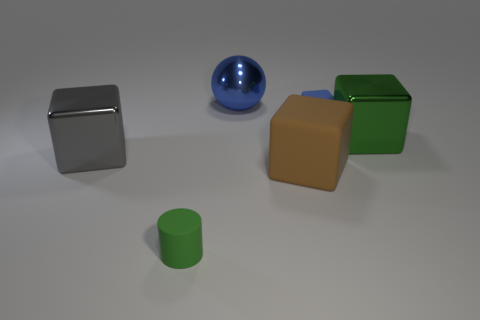What number of other things are there of the same size as the green shiny thing?
Give a very brief answer. 3. There is a brown object that is the same shape as the gray object; what is it made of?
Your answer should be very brief. Rubber. What is the material of the green thing behind the tiny thing in front of the green object that is behind the big rubber thing?
Your response must be concise. Metal. The other cube that is made of the same material as the big gray cube is what size?
Offer a terse response. Large. Is there any other thing of the same color as the cylinder?
Your answer should be very brief. Yes. There is a big shiny block that is right of the brown matte block; is its color the same as the tiny object that is left of the big metallic ball?
Your answer should be very brief. Yes. What is the color of the cube in front of the gray metallic cube?
Provide a short and direct response. Brown. There is a green metallic thing that is on the right side of the blue cube; is it the same size as the big brown matte object?
Provide a short and direct response. Yes. Is the number of brown matte objects less than the number of small yellow things?
Your response must be concise. No. There is a big shiny thing that is the same color as the small block; what shape is it?
Give a very brief answer. Sphere. 